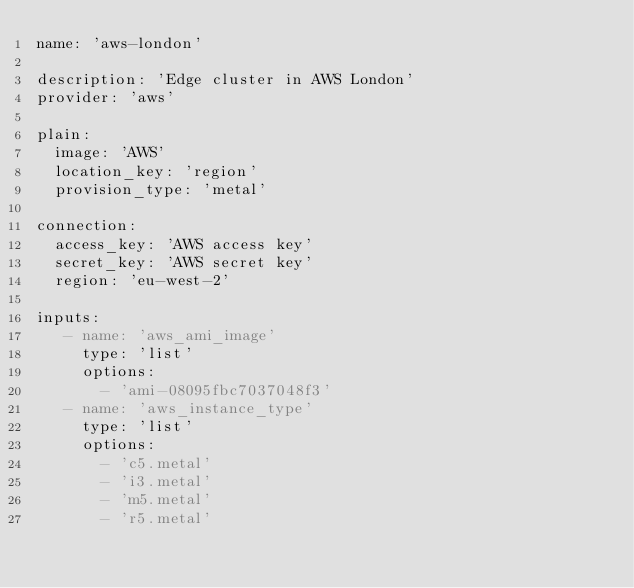Convert code to text. <code><loc_0><loc_0><loc_500><loc_500><_YAML_>name: 'aws-london'

description: 'Edge cluster in AWS London'
provider: 'aws'

plain:
  image: 'AWS'
  location_key: 'region'
  provision_type: 'metal'

connection:
  access_key: 'AWS access key'
  secret_key: 'AWS secret key'
  region: 'eu-west-2'

inputs:
   - name: 'aws_ami_image'
     type: 'list'
     options:
       - 'ami-08095fbc7037048f3'
   - name: 'aws_instance_type'
     type: 'list'
     options:
       - 'c5.metal'
       - 'i3.metal'
       - 'm5.metal'
       - 'r5.metal'
</code> 